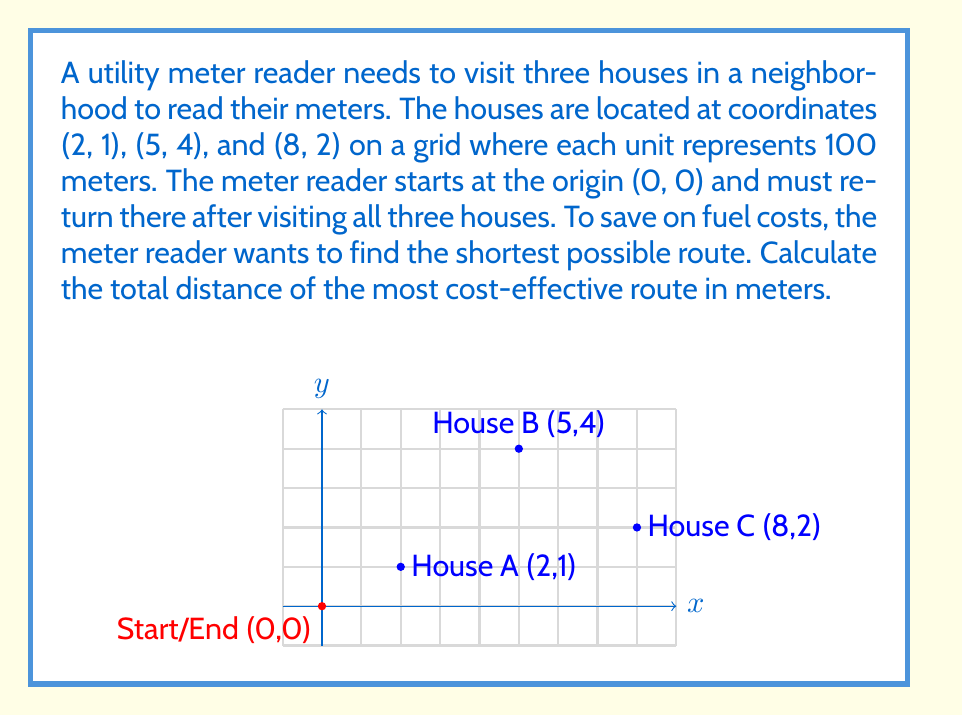Solve this math problem. To find the most cost-effective route, we need to calculate the distances between all points and determine the shortest path that visits all houses and returns to the starting point. This is a variation of the Traveling Salesman Problem.

Step 1: Calculate distances between all points using the distance formula:
$d = \sqrt{(x_2-x_1)^2 + (y_2-y_1)^2}$

- Start to A: $d_{SA} = \sqrt{(2-0)^2 + (1-0)^2} = \sqrt{5}$
- Start to B: $d_{SB} = \sqrt{(5-0)^2 + (4-0)^2} = \sqrt{41}$
- Start to C: $d_{SC} = \sqrt{(8-0)^2 + (2-0)^2} = \sqrt{68}$
- A to B: $d_{AB} = \sqrt{(5-2)^2 + (4-1)^2} = \sqrt{18}$
- A to C: $d_{AC} = \sqrt{(8-2)^2 + (2-1)^2} = \sqrt{37}$
- B to C: $d_{BC} = \sqrt{(8-5)^2 + (2-4)^2} = \sqrt{13}$

Step 2: Consider all possible routes:
1. Start → A → B → C → Start
2. Start → A → C → B → Start
3. Start → B → A → C → Start
4. Start → B → C → A → Start
5. Start → C → A → B → Start
6. Start → C → B → A → Start

Step 3: Calculate the total distance for each route:
1. $d_{SA} + d_{AB} + d_{BC} + d_{SC} = \sqrt{5} + \sqrt{18} + \sqrt{13} + \sqrt{68}$
2. $d_{SA} + d_{AC} + d_{BC} + d_{SB} = \sqrt{5} + \sqrt{37} + \sqrt{13} + \sqrt{41}$
3. $d_{SB} + d_{AB} + d_{AC} + d_{SC} = \sqrt{41} + \sqrt{18} + \sqrt{37} + \sqrt{68}$
4. $d_{SB} + d_{BC} + d_{AC} + d_{SA} = \sqrt{41} + \sqrt{13} + \sqrt{37} + \sqrt{5}$
5. $d_{SC} + d_{AC} + d_{AB} + d_{SB} = \sqrt{68} + \sqrt{37} + \sqrt{18} + \sqrt{41}$
6. $d_{SC} + d_{BC} + d_{AB} + d_{SA} = \sqrt{68} + \sqrt{13} + \sqrt{18} + \sqrt{5}$

Step 4: Compare the total distances and choose the shortest route.
The shortest route is option 6: Start → C → B → A → Start

Step 5: Calculate the total distance of the shortest route:
Total distance = $\sqrt{68} + \sqrt{13} + \sqrt{18} + \sqrt{5}$
$= 8.246 + 3.606 + 4.243 + 2.236 = 18.331$ units

Step 6: Convert to meters (1 unit = 100 meters):
18.331 * 100 = 1833.1 meters
Answer: The most cost-effective route for the utility meter reader is 1833.1 meters. 